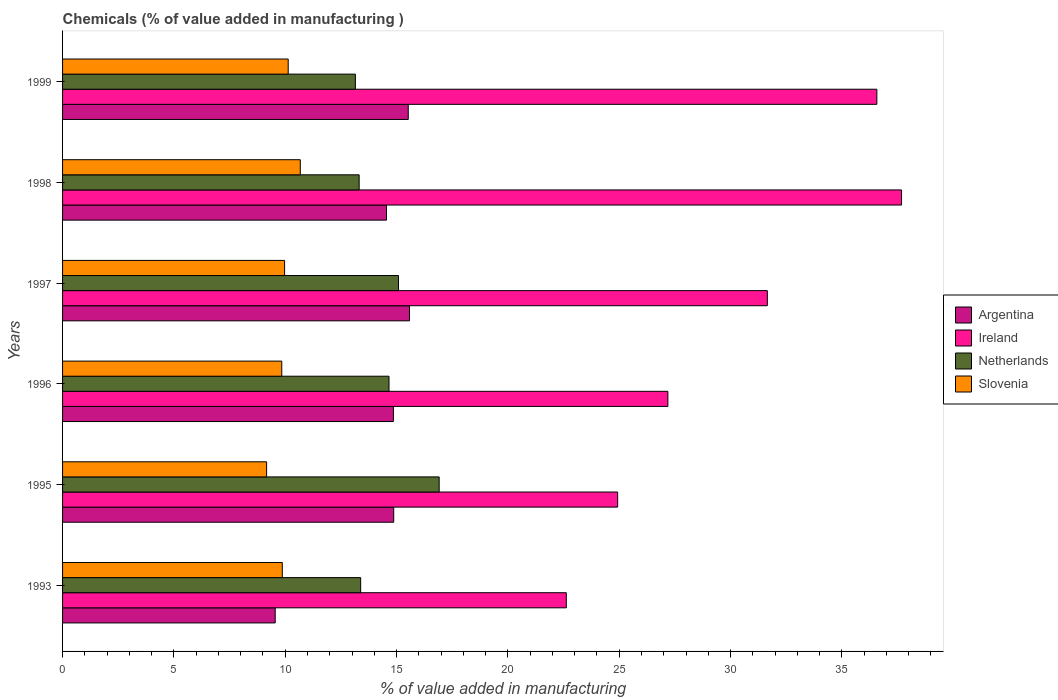How many different coloured bars are there?
Provide a short and direct response. 4. How many groups of bars are there?
Provide a short and direct response. 6. How many bars are there on the 3rd tick from the top?
Keep it short and to the point. 4. What is the label of the 1st group of bars from the top?
Keep it short and to the point. 1999. In how many cases, is the number of bars for a given year not equal to the number of legend labels?
Ensure brevity in your answer.  0. What is the value added in manufacturing chemicals in Slovenia in 1999?
Ensure brevity in your answer.  10.13. Across all years, what is the maximum value added in manufacturing chemicals in Argentina?
Provide a short and direct response. 15.58. Across all years, what is the minimum value added in manufacturing chemicals in Netherlands?
Offer a terse response. 13.15. In which year was the value added in manufacturing chemicals in Netherlands maximum?
Your response must be concise. 1995. What is the total value added in manufacturing chemicals in Argentina in the graph?
Your response must be concise. 84.94. What is the difference between the value added in manufacturing chemicals in Netherlands in 1995 and that in 1999?
Give a very brief answer. 3.76. What is the difference between the value added in manufacturing chemicals in Ireland in 1996 and the value added in manufacturing chemicals in Slovenia in 1997?
Your answer should be very brief. 17.21. What is the average value added in manufacturing chemicals in Ireland per year?
Offer a very short reply. 30.11. In the year 1995, what is the difference between the value added in manufacturing chemicals in Ireland and value added in manufacturing chemicals in Argentina?
Ensure brevity in your answer.  10.06. In how many years, is the value added in manufacturing chemicals in Slovenia greater than 36 %?
Give a very brief answer. 0. What is the ratio of the value added in manufacturing chemicals in Slovenia in 1995 to that in 1999?
Offer a terse response. 0.9. Is the value added in manufacturing chemicals in Netherlands in 1993 less than that in 1996?
Offer a very short reply. Yes. Is the difference between the value added in manufacturing chemicals in Ireland in 1993 and 1996 greater than the difference between the value added in manufacturing chemicals in Argentina in 1993 and 1996?
Your response must be concise. Yes. What is the difference between the highest and the second highest value added in manufacturing chemicals in Slovenia?
Keep it short and to the point. 0.54. What is the difference between the highest and the lowest value added in manufacturing chemicals in Slovenia?
Your response must be concise. 1.51. Is it the case that in every year, the sum of the value added in manufacturing chemicals in Netherlands and value added in manufacturing chemicals in Ireland is greater than the sum of value added in manufacturing chemicals in Argentina and value added in manufacturing chemicals in Slovenia?
Your answer should be compact. Yes. What does the 1st bar from the bottom in 1993 represents?
Keep it short and to the point. Argentina. Is it the case that in every year, the sum of the value added in manufacturing chemicals in Netherlands and value added in manufacturing chemicals in Slovenia is greater than the value added in manufacturing chemicals in Argentina?
Provide a succinct answer. Yes. How many years are there in the graph?
Keep it short and to the point. 6. What is the difference between two consecutive major ticks on the X-axis?
Provide a short and direct response. 5. Are the values on the major ticks of X-axis written in scientific E-notation?
Your answer should be very brief. No. Where does the legend appear in the graph?
Make the answer very short. Center right. How are the legend labels stacked?
Offer a very short reply. Vertical. What is the title of the graph?
Provide a short and direct response. Chemicals (% of value added in manufacturing ). What is the label or title of the X-axis?
Offer a very short reply. % of value added in manufacturing. What is the % of value added in manufacturing in Argentina in 1993?
Offer a very short reply. 9.55. What is the % of value added in manufacturing of Ireland in 1993?
Ensure brevity in your answer.  22.62. What is the % of value added in manufacturing in Netherlands in 1993?
Your response must be concise. 13.39. What is the % of value added in manufacturing of Slovenia in 1993?
Keep it short and to the point. 9.87. What is the % of value added in manufacturing in Argentina in 1995?
Make the answer very short. 14.87. What is the % of value added in manufacturing in Ireland in 1995?
Offer a terse response. 24.93. What is the % of value added in manufacturing in Netherlands in 1995?
Your answer should be compact. 16.91. What is the % of value added in manufacturing of Slovenia in 1995?
Provide a succinct answer. 9.16. What is the % of value added in manufacturing of Argentina in 1996?
Offer a terse response. 14.86. What is the % of value added in manufacturing of Ireland in 1996?
Make the answer very short. 27.19. What is the % of value added in manufacturing in Netherlands in 1996?
Provide a succinct answer. 14.66. What is the % of value added in manufacturing in Slovenia in 1996?
Offer a terse response. 9.84. What is the % of value added in manufacturing in Argentina in 1997?
Your answer should be very brief. 15.58. What is the % of value added in manufacturing in Ireland in 1997?
Your answer should be very brief. 31.65. What is the % of value added in manufacturing of Netherlands in 1997?
Your answer should be very brief. 15.09. What is the % of value added in manufacturing of Slovenia in 1997?
Keep it short and to the point. 9.97. What is the % of value added in manufacturing of Argentina in 1998?
Provide a short and direct response. 14.55. What is the % of value added in manufacturing in Ireland in 1998?
Ensure brevity in your answer.  37.68. What is the % of value added in manufacturing in Netherlands in 1998?
Make the answer very short. 13.32. What is the % of value added in manufacturing in Slovenia in 1998?
Your answer should be compact. 10.68. What is the % of value added in manufacturing of Argentina in 1999?
Keep it short and to the point. 15.53. What is the % of value added in manufacturing in Ireland in 1999?
Your response must be concise. 36.57. What is the % of value added in manufacturing in Netherlands in 1999?
Your response must be concise. 13.15. What is the % of value added in manufacturing of Slovenia in 1999?
Your response must be concise. 10.13. Across all years, what is the maximum % of value added in manufacturing in Argentina?
Ensure brevity in your answer.  15.58. Across all years, what is the maximum % of value added in manufacturing in Ireland?
Your answer should be very brief. 37.68. Across all years, what is the maximum % of value added in manufacturing of Netherlands?
Your response must be concise. 16.91. Across all years, what is the maximum % of value added in manufacturing of Slovenia?
Ensure brevity in your answer.  10.68. Across all years, what is the minimum % of value added in manufacturing of Argentina?
Provide a short and direct response. 9.55. Across all years, what is the minimum % of value added in manufacturing of Ireland?
Provide a succinct answer. 22.62. Across all years, what is the minimum % of value added in manufacturing in Netherlands?
Provide a succinct answer. 13.15. Across all years, what is the minimum % of value added in manufacturing of Slovenia?
Make the answer very short. 9.16. What is the total % of value added in manufacturing of Argentina in the graph?
Provide a short and direct response. 84.94. What is the total % of value added in manufacturing in Ireland in the graph?
Provide a short and direct response. 180.65. What is the total % of value added in manufacturing of Netherlands in the graph?
Provide a short and direct response. 86.52. What is the total % of value added in manufacturing of Slovenia in the graph?
Offer a terse response. 59.66. What is the difference between the % of value added in manufacturing of Argentina in 1993 and that in 1995?
Provide a succinct answer. -5.32. What is the difference between the % of value added in manufacturing in Ireland in 1993 and that in 1995?
Keep it short and to the point. -2.31. What is the difference between the % of value added in manufacturing in Netherlands in 1993 and that in 1995?
Ensure brevity in your answer.  -3.53. What is the difference between the % of value added in manufacturing in Slovenia in 1993 and that in 1995?
Ensure brevity in your answer.  0.7. What is the difference between the % of value added in manufacturing of Argentina in 1993 and that in 1996?
Offer a terse response. -5.31. What is the difference between the % of value added in manufacturing of Ireland in 1993 and that in 1996?
Make the answer very short. -4.56. What is the difference between the % of value added in manufacturing in Netherlands in 1993 and that in 1996?
Keep it short and to the point. -1.27. What is the difference between the % of value added in manufacturing of Slovenia in 1993 and that in 1996?
Keep it short and to the point. 0.02. What is the difference between the % of value added in manufacturing in Argentina in 1993 and that in 1997?
Ensure brevity in your answer.  -6.03. What is the difference between the % of value added in manufacturing in Ireland in 1993 and that in 1997?
Provide a succinct answer. -9.03. What is the difference between the % of value added in manufacturing in Netherlands in 1993 and that in 1997?
Your answer should be compact. -1.7. What is the difference between the % of value added in manufacturing of Slovenia in 1993 and that in 1997?
Make the answer very short. -0.1. What is the difference between the % of value added in manufacturing of Argentina in 1993 and that in 1998?
Offer a terse response. -5. What is the difference between the % of value added in manufacturing of Ireland in 1993 and that in 1998?
Provide a succinct answer. -15.06. What is the difference between the % of value added in manufacturing in Netherlands in 1993 and that in 1998?
Provide a short and direct response. 0.07. What is the difference between the % of value added in manufacturing in Slovenia in 1993 and that in 1998?
Your response must be concise. -0.81. What is the difference between the % of value added in manufacturing in Argentina in 1993 and that in 1999?
Offer a terse response. -5.98. What is the difference between the % of value added in manufacturing of Ireland in 1993 and that in 1999?
Provide a succinct answer. -13.95. What is the difference between the % of value added in manufacturing in Netherlands in 1993 and that in 1999?
Your answer should be compact. 0.24. What is the difference between the % of value added in manufacturing in Slovenia in 1993 and that in 1999?
Make the answer very short. -0.27. What is the difference between the % of value added in manufacturing of Argentina in 1995 and that in 1996?
Your answer should be very brief. 0.01. What is the difference between the % of value added in manufacturing in Ireland in 1995 and that in 1996?
Your answer should be very brief. -2.26. What is the difference between the % of value added in manufacturing of Netherlands in 1995 and that in 1996?
Provide a short and direct response. 2.25. What is the difference between the % of value added in manufacturing in Slovenia in 1995 and that in 1996?
Offer a terse response. -0.68. What is the difference between the % of value added in manufacturing of Argentina in 1995 and that in 1997?
Offer a terse response. -0.71. What is the difference between the % of value added in manufacturing in Ireland in 1995 and that in 1997?
Offer a terse response. -6.72. What is the difference between the % of value added in manufacturing of Netherlands in 1995 and that in 1997?
Offer a very short reply. 1.83. What is the difference between the % of value added in manufacturing of Slovenia in 1995 and that in 1997?
Ensure brevity in your answer.  -0.81. What is the difference between the % of value added in manufacturing in Argentina in 1995 and that in 1998?
Make the answer very short. 0.32. What is the difference between the % of value added in manufacturing of Ireland in 1995 and that in 1998?
Give a very brief answer. -12.75. What is the difference between the % of value added in manufacturing in Netherlands in 1995 and that in 1998?
Provide a succinct answer. 3.59. What is the difference between the % of value added in manufacturing of Slovenia in 1995 and that in 1998?
Make the answer very short. -1.51. What is the difference between the % of value added in manufacturing in Argentina in 1995 and that in 1999?
Your answer should be very brief. -0.65. What is the difference between the % of value added in manufacturing in Ireland in 1995 and that in 1999?
Provide a succinct answer. -11.64. What is the difference between the % of value added in manufacturing of Netherlands in 1995 and that in 1999?
Provide a succinct answer. 3.76. What is the difference between the % of value added in manufacturing in Slovenia in 1995 and that in 1999?
Make the answer very short. -0.97. What is the difference between the % of value added in manufacturing in Argentina in 1996 and that in 1997?
Provide a short and direct response. -0.72. What is the difference between the % of value added in manufacturing in Ireland in 1996 and that in 1997?
Offer a very short reply. -4.47. What is the difference between the % of value added in manufacturing of Netherlands in 1996 and that in 1997?
Your answer should be compact. -0.43. What is the difference between the % of value added in manufacturing in Slovenia in 1996 and that in 1997?
Keep it short and to the point. -0.13. What is the difference between the % of value added in manufacturing in Argentina in 1996 and that in 1998?
Offer a terse response. 0.31. What is the difference between the % of value added in manufacturing of Ireland in 1996 and that in 1998?
Provide a succinct answer. -10.49. What is the difference between the % of value added in manufacturing of Netherlands in 1996 and that in 1998?
Provide a short and direct response. 1.34. What is the difference between the % of value added in manufacturing in Slovenia in 1996 and that in 1998?
Your answer should be compact. -0.83. What is the difference between the % of value added in manufacturing in Argentina in 1996 and that in 1999?
Keep it short and to the point. -0.67. What is the difference between the % of value added in manufacturing of Ireland in 1996 and that in 1999?
Provide a succinct answer. -9.39. What is the difference between the % of value added in manufacturing in Netherlands in 1996 and that in 1999?
Your response must be concise. 1.51. What is the difference between the % of value added in manufacturing of Slovenia in 1996 and that in 1999?
Provide a short and direct response. -0.29. What is the difference between the % of value added in manufacturing of Argentina in 1997 and that in 1998?
Make the answer very short. 1.03. What is the difference between the % of value added in manufacturing in Ireland in 1997 and that in 1998?
Keep it short and to the point. -6.03. What is the difference between the % of value added in manufacturing in Netherlands in 1997 and that in 1998?
Provide a succinct answer. 1.77. What is the difference between the % of value added in manufacturing in Slovenia in 1997 and that in 1998?
Provide a succinct answer. -0.7. What is the difference between the % of value added in manufacturing in Argentina in 1997 and that in 1999?
Your response must be concise. 0.06. What is the difference between the % of value added in manufacturing in Ireland in 1997 and that in 1999?
Offer a very short reply. -4.92. What is the difference between the % of value added in manufacturing of Netherlands in 1997 and that in 1999?
Make the answer very short. 1.94. What is the difference between the % of value added in manufacturing of Slovenia in 1997 and that in 1999?
Make the answer very short. -0.16. What is the difference between the % of value added in manufacturing of Argentina in 1998 and that in 1999?
Offer a terse response. -0.98. What is the difference between the % of value added in manufacturing in Ireland in 1998 and that in 1999?
Keep it short and to the point. 1.11. What is the difference between the % of value added in manufacturing in Netherlands in 1998 and that in 1999?
Your answer should be very brief. 0.17. What is the difference between the % of value added in manufacturing of Slovenia in 1998 and that in 1999?
Your answer should be very brief. 0.54. What is the difference between the % of value added in manufacturing of Argentina in 1993 and the % of value added in manufacturing of Ireland in 1995?
Offer a terse response. -15.38. What is the difference between the % of value added in manufacturing in Argentina in 1993 and the % of value added in manufacturing in Netherlands in 1995?
Your answer should be compact. -7.36. What is the difference between the % of value added in manufacturing in Argentina in 1993 and the % of value added in manufacturing in Slovenia in 1995?
Offer a very short reply. 0.39. What is the difference between the % of value added in manufacturing in Ireland in 1993 and the % of value added in manufacturing in Netherlands in 1995?
Provide a succinct answer. 5.71. What is the difference between the % of value added in manufacturing in Ireland in 1993 and the % of value added in manufacturing in Slovenia in 1995?
Your answer should be very brief. 13.46. What is the difference between the % of value added in manufacturing in Netherlands in 1993 and the % of value added in manufacturing in Slovenia in 1995?
Your answer should be compact. 4.22. What is the difference between the % of value added in manufacturing of Argentina in 1993 and the % of value added in manufacturing of Ireland in 1996?
Offer a very short reply. -17.64. What is the difference between the % of value added in manufacturing of Argentina in 1993 and the % of value added in manufacturing of Netherlands in 1996?
Offer a very short reply. -5.11. What is the difference between the % of value added in manufacturing of Argentina in 1993 and the % of value added in manufacturing of Slovenia in 1996?
Offer a terse response. -0.3. What is the difference between the % of value added in manufacturing in Ireland in 1993 and the % of value added in manufacturing in Netherlands in 1996?
Ensure brevity in your answer.  7.96. What is the difference between the % of value added in manufacturing in Ireland in 1993 and the % of value added in manufacturing in Slovenia in 1996?
Offer a very short reply. 12.78. What is the difference between the % of value added in manufacturing of Netherlands in 1993 and the % of value added in manufacturing of Slovenia in 1996?
Make the answer very short. 3.54. What is the difference between the % of value added in manufacturing of Argentina in 1993 and the % of value added in manufacturing of Ireland in 1997?
Make the answer very short. -22.1. What is the difference between the % of value added in manufacturing in Argentina in 1993 and the % of value added in manufacturing in Netherlands in 1997?
Offer a very short reply. -5.54. What is the difference between the % of value added in manufacturing in Argentina in 1993 and the % of value added in manufacturing in Slovenia in 1997?
Offer a very short reply. -0.42. What is the difference between the % of value added in manufacturing in Ireland in 1993 and the % of value added in manufacturing in Netherlands in 1997?
Your response must be concise. 7.54. What is the difference between the % of value added in manufacturing in Ireland in 1993 and the % of value added in manufacturing in Slovenia in 1997?
Keep it short and to the point. 12.65. What is the difference between the % of value added in manufacturing in Netherlands in 1993 and the % of value added in manufacturing in Slovenia in 1997?
Offer a terse response. 3.42. What is the difference between the % of value added in manufacturing of Argentina in 1993 and the % of value added in manufacturing of Ireland in 1998?
Offer a very short reply. -28.13. What is the difference between the % of value added in manufacturing of Argentina in 1993 and the % of value added in manufacturing of Netherlands in 1998?
Give a very brief answer. -3.77. What is the difference between the % of value added in manufacturing in Argentina in 1993 and the % of value added in manufacturing in Slovenia in 1998?
Offer a very short reply. -1.13. What is the difference between the % of value added in manufacturing of Ireland in 1993 and the % of value added in manufacturing of Netherlands in 1998?
Your answer should be very brief. 9.3. What is the difference between the % of value added in manufacturing in Ireland in 1993 and the % of value added in manufacturing in Slovenia in 1998?
Your response must be concise. 11.95. What is the difference between the % of value added in manufacturing in Netherlands in 1993 and the % of value added in manufacturing in Slovenia in 1998?
Ensure brevity in your answer.  2.71. What is the difference between the % of value added in manufacturing of Argentina in 1993 and the % of value added in manufacturing of Ireland in 1999?
Your answer should be very brief. -27.02. What is the difference between the % of value added in manufacturing of Argentina in 1993 and the % of value added in manufacturing of Netherlands in 1999?
Your response must be concise. -3.6. What is the difference between the % of value added in manufacturing of Argentina in 1993 and the % of value added in manufacturing of Slovenia in 1999?
Your answer should be compact. -0.58. What is the difference between the % of value added in manufacturing in Ireland in 1993 and the % of value added in manufacturing in Netherlands in 1999?
Provide a succinct answer. 9.47. What is the difference between the % of value added in manufacturing in Ireland in 1993 and the % of value added in manufacturing in Slovenia in 1999?
Keep it short and to the point. 12.49. What is the difference between the % of value added in manufacturing in Netherlands in 1993 and the % of value added in manufacturing in Slovenia in 1999?
Ensure brevity in your answer.  3.25. What is the difference between the % of value added in manufacturing of Argentina in 1995 and the % of value added in manufacturing of Ireland in 1996?
Keep it short and to the point. -12.31. What is the difference between the % of value added in manufacturing in Argentina in 1995 and the % of value added in manufacturing in Netherlands in 1996?
Provide a short and direct response. 0.21. What is the difference between the % of value added in manufacturing of Argentina in 1995 and the % of value added in manufacturing of Slovenia in 1996?
Your response must be concise. 5.03. What is the difference between the % of value added in manufacturing of Ireland in 1995 and the % of value added in manufacturing of Netherlands in 1996?
Give a very brief answer. 10.27. What is the difference between the % of value added in manufacturing of Ireland in 1995 and the % of value added in manufacturing of Slovenia in 1996?
Provide a short and direct response. 15.09. What is the difference between the % of value added in manufacturing of Netherlands in 1995 and the % of value added in manufacturing of Slovenia in 1996?
Give a very brief answer. 7.07. What is the difference between the % of value added in manufacturing in Argentina in 1995 and the % of value added in manufacturing in Ireland in 1997?
Your answer should be very brief. -16.78. What is the difference between the % of value added in manufacturing in Argentina in 1995 and the % of value added in manufacturing in Netherlands in 1997?
Provide a short and direct response. -0.21. What is the difference between the % of value added in manufacturing of Argentina in 1995 and the % of value added in manufacturing of Slovenia in 1997?
Make the answer very short. 4.9. What is the difference between the % of value added in manufacturing of Ireland in 1995 and the % of value added in manufacturing of Netherlands in 1997?
Provide a succinct answer. 9.84. What is the difference between the % of value added in manufacturing in Ireland in 1995 and the % of value added in manufacturing in Slovenia in 1997?
Ensure brevity in your answer.  14.96. What is the difference between the % of value added in manufacturing in Netherlands in 1995 and the % of value added in manufacturing in Slovenia in 1997?
Provide a short and direct response. 6.94. What is the difference between the % of value added in manufacturing of Argentina in 1995 and the % of value added in manufacturing of Ireland in 1998?
Provide a succinct answer. -22.81. What is the difference between the % of value added in manufacturing in Argentina in 1995 and the % of value added in manufacturing in Netherlands in 1998?
Your response must be concise. 1.55. What is the difference between the % of value added in manufacturing in Argentina in 1995 and the % of value added in manufacturing in Slovenia in 1998?
Your response must be concise. 4.2. What is the difference between the % of value added in manufacturing of Ireland in 1995 and the % of value added in manufacturing of Netherlands in 1998?
Give a very brief answer. 11.61. What is the difference between the % of value added in manufacturing of Ireland in 1995 and the % of value added in manufacturing of Slovenia in 1998?
Ensure brevity in your answer.  14.25. What is the difference between the % of value added in manufacturing of Netherlands in 1995 and the % of value added in manufacturing of Slovenia in 1998?
Your response must be concise. 6.24. What is the difference between the % of value added in manufacturing of Argentina in 1995 and the % of value added in manufacturing of Ireland in 1999?
Your answer should be compact. -21.7. What is the difference between the % of value added in manufacturing in Argentina in 1995 and the % of value added in manufacturing in Netherlands in 1999?
Offer a terse response. 1.72. What is the difference between the % of value added in manufacturing of Argentina in 1995 and the % of value added in manufacturing of Slovenia in 1999?
Ensure brevity in your answer.  4.74. What is the difference between the % of value added in manufacturing of Ireland in 1995 and the % of value added in manufacturing of Netherlands in 1999?
Keep it short and to the point. 11.78. What is the difference between the % of value added in manufacturing of Ireland in 1995 and the % of value added in manufacturing of Slovenia in 1999?
Keep it short and to the point. 14.8. What is the difference between the % of value added in manufacturing in Netherlands in 1995 and the % of value added in manufacturing in Slovenia in 1999?
Make the answer very short. 6.78. What is the difference between the % of value added in manufacturing of Argentina in 1996 and the % of value added in manufacturing of Ireland in 1997?
Offer a terse response. -16.79. What is the difference between the % of value added in manufacturing in Argentina in 1996 and the % of value added in manufacturing in Netherlands in 1997?
Your response must be concise. -0.23. What is the difference between the % of value added in manufacturing in Argentina in 1996 and the % of value added in manufacturing in Slovenia in 1997?
Offer a terse response. 4.89. What is the difference between the % of value added in manufacturing in Ireland in 1996 and the % of value added in manufacturing in Netherlands in 1997?
Your answer should be very brief. 12.1. What is the difference between the % of value added in manufacturing in Ireland in 1996 and the % of value added in manufacturing in Slovenia in 1997?
Your answer should be very brief. 17.21. What is the difference between the % of value added in manufacturing of Netherlands in 1996 and the % of value added in manufacturing of Slovenia in 1997?
Ensure brevity in your answer.  4.69. What is the difference between the % of value added in manufacturing of Argentina in 1996 and the % of value added in manufacturing of Ireland in 1998?
Your answer should be compact. -22.82. What is the difference between the % of value added in manufacturing in Argentina in 1996 and the % of value added in manufacturing in Netherlands in 1998?
Keep it short and to the point. 1.54. What is the difference between the % of value added in manufacturing in Argentina in 1996 and the % of value added in manufacturing in Slovenia in 1998?
Your answer should be compact. 4.18. What is the difference between the % of value added in manufacturing of Ireland in 1996 and the % of value added in manufacturing of Netherlands in 1998?
Ensure brevity in your answer.  13.87. What is the difference between the % of value added in manufacturing in Ireland in 1996 and the % of value added in manufacturing in Slovenia in 1998?
Provide a succinct answer. 16.51. What is the difference between the % of value added in manufacturing of Netherlands in 1996 and the % of value added in manufacturing of Slovenia in 1998?
Provide a succinct answer. 3.99. What is the difference between the % of value added in manufacturing of Argentina in 1996 and the % of value added in manufacturing of Ireland in 1999?
Make the answer very short. -21.71. What is the difference between the % of value added in manufacturing in Argentina in 1996 and the % of value added in manufacturing in Netherlands in 1999?
Keep it short and to the point. 1.71. What is the difference between the % of value added in manufacturing of Argentina in 1996 and the % of value added in manufacturing of Slovenia in 1999?
Provide a succinct answer. 4.72. What is the difference between the % of value added in manufacturing in Ireland in 1996 and the % of value added in manufacturing in Netherlands in 1999?
Make the answer very short. 14.04. What is the difference between the % of value added in manufacturing of Ireland in 1996 and the % of value added in manufacturing of Slovenia in 1999?
Give a very brief answer. 17.05. What is the difference between the % of value added in manufacturing of Netherlands in 1996 and the % of value added in manufacturing of Slovenia in 1999?
Provide a succinct answer. 4.53. What is the difference between the % of value added in manufacturing of Argentina in 1997 and the % of value added in manufacturing of Ireland in 1998?
Ensure brevity in your answer.  -22.1. What is the difference between the % of value added in manufacturing in Argentina in 1997 and the % of value added in manufacturing in Netherlands in 1998?
Offer a terse response. 2.26. What is the difference between the % of value added in manufacturing in Argentina in 1997 and the % of value added in manufacturing in Slovenia in 1998?
Your response must be concise. 4.9. What is the difference between the % of value added in manufacturing in Ireland in 1997 and the % of value added in manufacturing in Netherlands in 1998?
Provide a succinct answer. 18.33. What is the difference between the % of value added in manufacturing in Ireland in 1997 and the % of value added in manufacturing in Slovenia in 1998?
Your response must be concise. 20.98. What is the difference between the % of value added in manufacturing of Netherlands in 1997 and the % of value added in manufacturing of Slovenia in 1998?
Your answer should be compact. 4.41. What is the difference between the % of value added in manufacturing in Argentina in 1997 and the % of value added in manufacturing in Ireland in 1999?
Your response must be concise. -20.99. What is the difference between the % of value added in manufacturing in Argentina in 1997 and the % of value added in manufacturing in Netherlands in 1999?
Your response must be concise. 2.43. What is the difference between the % of value added in manufacturing of Argentina in 1997 and the % of value added in manufacturing of Slovenia in 1999?
Provide a short and direct response. 5.45. What is the difference between the % of value added in manufacturing of Ireland in 1997 and the % of value added in manufacturing of Netherlands in 1999?
Offer a terse response. 18.5. What is the difference between the % of value added in manufacturing in Ireland in 1997 and the % of value added in manufacturing in Slovenia in 1999?
Provide a short and direct response. 21.52. What is the difference between the % of value added in manufacturing in Netherlands in 1997 and the % of value added in manufacturing in Slovenia in 1999?
Provide a succinct answer. 4.95. What is the difference between the % of value added in manufacturing of Argentina in 1998 and the % of value added in manufacturing of Ireland in 1999?
Provide a succinct answer. -22.02. What is the difference between the % of value added in manufacturing of Argentina in 1998 and the % of value added in manufacturing of Netherlands in 1999?
Offer a terse response. 1.4. What is the difference between the % of value added in manufacturing of Argentina in 1998 and the % of value added in manufacturing of Slovenia in 1999?
Offer a very short reply. 4.41. What is the difference between the % of value added in manufacturing of Ireland in 1998 and the % of value added in manufacturing of Netherlands in 1999?
Provide a succinct answer. 24.53. What is the difference between the % of value added in manufacturing of Ireland in 1998 and the % of value added in manufacturing of Slovenia in 1999?
Provide a short and direct response. 27.55. What is the difference between the % of value added in manufacturing in Netherlands in 1998 and the % of value added in manufacturing in Slovenia in 1999?
Give a very brief answer. 3.19. What is the average % of value added in manufacturing of Argentina per year?
Make the answer very short. 14.16. What is the average % of value added in manufacturing in Ireland per year?
Keep it short and to the point. 30.11. What is the average % of value added in manufacturing of Netherlands per year?
Provide a succinct answer. 14.42. What is the average % of value added in manufacturing of Slovenia per year?
Offer a very short reply. 9.94. In the year 1993, what is the difference between the % of value added in manufacturing of Argentina and % of value added in manufacturing of Ireland?
Make the answer very short. -13.07. In the year 1993, what is the difference between the % of value added in manufacturing of Argentina and % of value added in manufacturing of Netherlands?
Provide a succinct answer. -3.84. In the year 1993, what is the difference between the % of value added in manufacturing in Argentina and % of value added in manufacturing in Slovenia?
Your answer should be very brief. -0.32. In the year 1993, what is the difference between the % of value added in manufacturing of Ireland and % of value added in manufacturing of Netherlands?
Provide a short and direct response. 9.24. In the year 1993, what is the difference between the % of value added in manufacturing of Ireland and % of value added in manufacturing of Slovenia?
Provide a short and direct response. 12.76. In the year 1993, what is the difference between the % of value added in manufacturing of Netherlands and % of value added in manufacturing of Slovenia?
Give a very brief answer. 3.52. In the year 1995, what is the difference between the % of value added in manufacturing in Argentina and % of value added in manufacturing in Ireland?
Provide a succinct answer. -10.06. In the year 1995, what is the difference between the % of value added in manufacturing of Argentina and % of value added in manufacturing of Netherlands?
Your response must be concise. -2.04. In the year 1995, what is the difference between the % of value added in manufacturing in Argentina and % of value added in manufacturing in Slovenia?
Ensure brevity in your answer.  5.71. In the year 1995, what is the difference between the % of value added in manufacturing of Ireland and % of value added in manufacturing of Netherlands?
Your response must be concise. 8.02. In the year 1995, what is the difference between the % of value added in manufacturing in Ireland and % of value added in manufacturing in Slovenia?
Offer a very short reply. 15.77. In the year 1995, what is the difference between the % of value added in manufacturing of Netherlands and % of value added in manufacturing of Slovenia?
Keep it short and to the point. 7.75. In the year 1996, what is the difference between the % of value added in manufacturing of Argentina and % of value added in manufacturing of Ireland?
Offer a very short reply. -12.33. In the year 1996, what is the difference between the % of value added in manufacturing of Argentina and % of value added in manufacturing of Netherlands?
Keep it short and to the point. 0.2. In the year 1996, what is the difference between the % of value added in manufacturing in Argentina and % of value added in manufacturing in Slovenia?
Give a very brief answer. 5.01. In the year 1996, what is the difference between the % of value added in manufacturing in Ireland and % of value added in manufacturing in Netherlands?
Your answer should be compact. 12.52. In the year 1996, what is the difference between the % of value added in manufacturing of Ireland and % of value added in manufacturing of Slovenia?
Your answer should be compact. 17.34. In the year 1996, what is the difference between the % of value added in manufacturing in Netherlands and % of value added in manufacturing in Slovenia?
Your answer should be very brief. 4.82. In the year 1997, what is the difference between the % of value added in manufacturing in Argentina and % of value added in manufacturing in Ireland?
Give a very brief answer. -16.07. In the year 1997, what is the difference between the % of value added in manufacturing in Argentina and % of value added in manufacturing in Netherlands?
Offer a terse response. 0.49. In the year 1997, what is the difference between the % of value added in manufacturing of Argentina and % of value added in manufacturing of Slovenia?
Offer a terse response. 5.61. In the year 1997, what is the difference between the % of value added in manufacturing of Ireland and % of value added in manufacturing of Netherlands?
Keep it short and to the point. 16.57. In the year 1997, what is the difference between the % of value added in manufacturing in Ireland and % of value added in manufacturing in Slovenia?
Give a very brief answer. 21.68. In the year 1997, what is the difference between the % of value added in manufacturing of Netherlands and % of value added in manufacturing of Slovenia?
Your answer should be compact. 5.12. In the year 1998, what is the difference between the % of value added in manufacturing in Argentina and % of value added in manufacturing in Ireland?
Provide a short and direct response. -23.13. In the year 1998, what is the difference between the % of value added in manufacturing in Argentina and % of value added in manufacturing in Netherlands?
Offer a very short reply. 1.23. In the year 1998, what is the difference between the % of value added in manufacturing in Argentina and % of value added in manufacturing in Slovenia?
Your answer should be very brief. 3.87. In the year 1998, what is the difference between the % of value added in manufacturing of Ireland and % of value added in manufacturing of Netherlands?
Offer a terse response. 24.36. In the year 1998, what is the difference between the % of value added in manufacturing in Ireland and % of value added in manufacturing in Slovenia?
Offer a terse response. 27. In the year 1998, what is the difference between the % of value added in manufacturing in Netherlands and % of value added in manufacturing in Slovenia?
Your answer should be very brief. 2.64. In the year 1999, what is the difference between the % of value added in manufacturing in Argentina and % of value added in manufacturing in Ireland?
Give a very brief answer. -21.05. In the year 1999, what is the difference between the % of value added in manufacturing of Argentina and % of value added in manufacturing of Netherlands?
Give a very brief answer. 2.37. In the year 1999, what is the difference between the % of value added in manufacturing of Argentina and % of value added in manufacturing of Slovenia?
Keep it short and to the point. 5.39. In the year 1999, what is the difference between the % of value added in manufacturing of Ireland and % of value added in manufacturing of Netherlands?
Offer a very short reply. 23.42. In the year 1999, what is the difference between the % of value added in manufacturing of Ireland and % of value added in manufacturing of Slovenia?
Keep it short and to the point. 26.44. In the year 1999, what is the difference between the % of value added in manufacturing of Netherlands and % of value added in manufacturing of Slovenia?
Your answer should be compact. 3.02. What is the ratio of the % of value added in manufacturing in Argentina in 1993 to that in 1995?
Offer a terse response. 0.64. What is the ratio of the % of value added in manufacturing in Ireland in 1993 to that in 1995?
Your answer should be very brief. 0.91. What is the ratio of the % of value added in manufacturing of Netherlands in 1993 to that in 1995?
Your response must be concise. 0.79. What is the ratio of the % of value added in manufacturing in Argentina in 1993 to that in 1996?
Provide a short and direct response. 0.64. What is the ratio of the % of value added in manufacturing of Ireland in 1993 to that in 1996?
Give a very brief answer. 0.83. What is the ratio of the % of value added in manufacturing of Netherlands in 1993 to that in 1996?
Your response must be concise. 0.91. What is the ratio of the % of value added in manufacturing of Slovenia in 1993 to that in 1996?
Give a very brief answer. 1. What is the ratio of the % of value added in manufacturing in Argentina in 1993 to that in 1997?
Make the answer very short. 0.61. What is the ratio of the % of value added in manufacturing in Ireland in 1993 to that in 1997?
Your answer should be very brief. 0.71. What is the ratio of the % of value added in manufacturing of Netherlands in 1993 to that in 1997?
Make the answer very short. 0.89. What is the ratio of the % of value added in manufacturing in Slovenia in 1993 to that in 1997?
Provide a short and direct response. 0.99. What is the ratio of the % of value added in manufacturing of Argentina in 1993 to that in 1998?
Give a very brief answer. 0.66. What is the ratio of the % of value added in manufacturing in Ireland in 1993 to that in 1998?
Provide a succinct answer. 0.6. What is the ratio of the % of value added in manufacturing of Slovenia in 1993 to that in 1998?
Make the answer very short. 0.92. What is the ratio of the % of value added in manufacturing of Argentina in 1993 to that in 1999?
Give a very brief answer. 0.62. What is the ratio of the % of value added in manufacturing of Ireland in 1993 to that in 1999?
Provide a short and direct response. 0.62. What is the ratio of the % of value added in manufacturing of Netherlands in 1993 to that in 1999?
Offer a very short reply. 1.02. What is the ratio of the % of value added in manufacturing of Slovenia in 1993 to that in 1999?
Offer a terse response. 0.97. What is the ratio of the % of value added in manufacturing in Argentina in 1995 to that in 1996?
Offer a very short reply. 1. What is the ratio of the % of value added in manufacturing of Ireland in 1995 to that in 1996?
Provide a short and direct response. 0.92. What is the ratio of the % of value added in manufacturing in Netherlands in 1995 to that in 1996?
Your answer should be very brief. 1.15. What is the ratio of the % of value added in manufacturing of Slovenia in 1995 to that in 1996?
Ensure brevity in your answer.  0.93. What is the ratio of the % of value added in manufacturing of Argentina in 1995 to that in 1997?
Provide a short and direct response. 0.95. What is the ratio of the % of value added in manufacturing of Ireland in 1995 to that in 1997?
Your answer should be very brief. 0.79. What is the ratio of the % of value added in manufacturing in Netherlands in 1995 to that in 1997?
Your answer should be compact. 1.12. What is the ratio of the % of value added in manufacturing in Slovenia in 1995 to that in 1997?
Your answer should be very brief. 0.92. What is the ratio of the % of value added in manufacturing in Argentina in 1995 to that in 1998?
Your response must be concise. 1.02. What is the ratio of the % of value added in manufacturing of Ireland in 1995 to that in 1998?
Offer a terse response. 0.66. What is the ratio of the % of value added in manufacturing of Netherlands in 1995 to that in 1998?
Make the answer very short. 1.27. What is the ratio of the % of value added in manufacturing of Slovenia in 1995 to that in 1998?
Provide a succinct answer. 0.86. What is the ratio of the % of value added in manufacturing in Argentina in 1995 to that in 1999?
Offer a terse response. 0.96. What is the ratio of the % of value added in manufacturing in Ireland in 1995 to that in 1999?
Give a very brief answer. 0.68. What is the ratio of the % of value added in manufacturing of Netherlands in 1995 to that in 1999?
Provide a short and direct response. 1.29. What is the ratio of the % of value added in manufacturing in Slovenia in 1995 to that in 1999?
Keep it short and to the point. 0.9. What is the ratio of the % of value added in manufacturing in Argentina in 1996 to that in 1997?
Offer a terse response. 0.95. What is the ratio of the % of value added in manufacturing in Ireland in 1996 to that in 1997?
Offer a very short reply. 0.86. What is the ratio of the % of value added in manufacturing in Netherlands in 1996 to that in 1997?
Offer a terse response. 0.97. What is the ratio of the % of value added in manufacturing in Slovenia in 1996 to that in 1997?
Offer a very short reply. 0.99. What is the ratio of the % of value added in manufacturing in Argentina in 1996 to that in 1998?
Offer a very short reply. 1.02. What is the ratio of the % of value added in manufacturing in Ireland in 1996 to that in 1998?
Provide a succinct answer. 0.72. What is the ratio of the % of value added in manufacturing in Netherlands in 1996 to that in 1998?
Provide a succinct answer. 1.1. What is the ratio of the % of value added in manufacturing of Slovenia in 1996 to that in 1998?
Ensure brevity in your answer.  0.92. What is the ratio of the % of value added in manufacturing in Argentina in 1996 to that in 1999?
Provide a short and direct response. 0.96. What is the ratio of the % of value added in manufacturing in Ireland in 1996 to that in 1999?
Provide a short and direct response. 0.74. What is the ratio of the % of value added in manufacturing of Netherlands in 1996 to that in 1999?
Give a very brief answer. 1.11. What is the ratio of the % of value added in manufacturing of Slovenia in 1996 to that in 1999?
Give a very brief answer. 0.97. What is the ratio of the % of value added in manufacturing in Argentina in 1997 to that in 1998?
Give a very brief answer. 1.07. What is the ratio of the % of value added in manufacturing in Ireland in 1997 to that in 1998?
Keep it short and to the point. 0.84. What is the ratio of the % of value added in manufacturing of Netherlands in 1997 to that in 1998?
Offer a very short reply. 1.13. What is the ratio of the % of value added in manufacturing in Slovenia in 1997 to that in 1998?
Make the answer very short. 0.93. What is the ratio of the % of value added in manufacturing of Ireland in 1997 to that in 1999?
Provide a short and direct response. 0.87. What is the ratio of the % of value added in manufacturing of Netherlands in 1997 to that in 1999?
Ensure brevity in your answer.  1.15. What is the ratio of the % of value added in manufacturing of Slovenia in 1997 to that in 1999?
Provide a short and direct response. 0.98. What is the ratio of the % of value added in manufacturing of Argentina in 1998 to that in 1999?
Make the answer very short. 0.94. What is the ratio of the % of value added in manufacturing of Ireland in 1998 to that in 1999?
Make the answer very short. 1.03. What is the ratio of the % of value added in manufacturing in Netherlands in 1998 to that in 1999?
Keep it short and to the point. 1.01. What is the ratio of the % of value added in manufacturing in Slovenia in 1998 to that in 1999?
Offer a very short reply. 1.05. What is the difference between the highest and the second highest % of value added in manufacturing in Argentina?
Ensure brevity in your answer.  0.06. What is the difference between the highest and the second highest % of value added in manufacturing of Ireland?
Give a very brief answer. 1.11. What is the difference between the highest and the second highest % of value added in manufacturing in Netherlands?
Keep it short and to the point. 1.83. What is the difference between the highest and the second highest % of value added in manufacturing of Slovenia?
Your answer should be very brief. 0.54. What is the difference between the highest and the lowest % of value added in manufacturing in Argentina?
Keep it short and to the point. 6.03. What is the difference between the highest and the lowest % of value added in manufacturing of Ireland?
Provide a succinct answer. 15.06. What is the difference between the highest and the lowest % of value added in manufacturing of Netherlands?
Give a very brief answer. 3.76. What is the difference between the highest and the lowest % of value added in manufacturing in Slovenia?
Your answer should be compact. 1.51. 